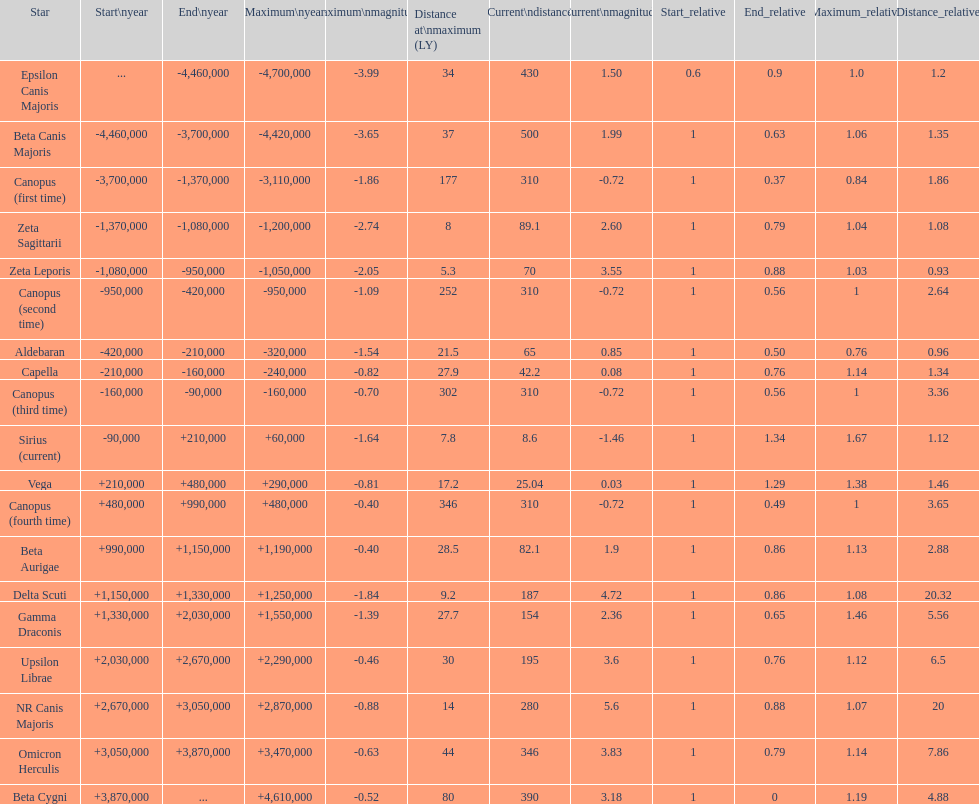Help me parse the entirety of this table. {'header': ['Star', 'Start\\nyear', 'End\\nyear', 'Maximum\\nyear', 'Maximum\\nmagnitude', 'Distance at\\nmaximum (LY)', 'Current\\ndistance', 'Current\\nmagnitude', 'Start_relative', 'End_relative', 'Maximum_relative', 'Distance_relative'], 'rows': [['Epsilon Canis Majoris', '...', '-4,460,000', '-4,700,000', '-3.99', '34', '430', '1.50', '0.6', '0.9', '1.0', '1.2'], ['Beta Canis Majoris', '-4,460,000', '-3,700,000', '-4,420,000', '-3.65', '37', '500', '1.99', '1', '0.63', '1.06', '1.35'], ['Canopus (first time)', '-3,700,000', '-1,370,000', '-3,110,000', '-1.86', '177', '310', '-0.72', '1', '0.37', '0.84', '1.86'], ['Zeta Sagittarii', '-1,370,000', '-1,080,000', '-1,200,000', '-2.74', '8', '89.1', '2.60', '1', '0.79', '1.04', '1.08'], ['Zeta Leporis', '-1,080,000', '-950,000', '-1,050,000', '-2.05', '5.3', '70', '3.55', '1', '0.88', '1.03', '0.93'], ['Canopus (second time)', '-950,000', '-420,000', '-950,000', '-1.09', '252', '310', '-0.72', '1', '0.56', '1', '2.64'], ['Aldebaran', '-420,000', '-210,000', '-320,000', '-1.54', '21.5', '65', '0.85', '1', '0.50', '0.76', '0.96'], ['Capella', '-210,000', '-160,000', '-240,000', '-0.82', '27.9', '42.2', '0.08', '1', '0.76', '1.14', '1.34'], ['Canopus (third time)', '-160,000', '-90,000', '-160,000', '-0.70', '302', '310', '-0.72', '1', '0.56', '1', '3.36'], ['Sirius (current)', '-90,000', '+210,000', '+60,000', '-1.64', '7.8', '8.6', '-1.46', '1', '1.34', '1.67', '1.12'], ['Vega', '+210,000', '+480,000', '+290,000', '-0.81', '17.2', '25.04', '0.03', '1', '1.29', '1.38', '1.46'], ['Canopus (fourth time)', '+480,000', '+990,000', '+480,000', '-0.40', '346', '310', '-0.72', '1', '0.49', '1', '3.65'], ['Beta Aurigae', '+990,000', '+1,150,000', '+1,190,000', '-0.40', '28.5', '82.1', '1.9', '1', '0.86', '1.13', '2.88'], ['Delta Scuti', '+1,150,000', '+1,330,000', '+1,250,000', '-1.84', '9.2', '187', '4.72', '1', '0.86', '1.08', '20.32'], ['Gamma Draconis', '+1,330,000', '+2,030,000', '+1,550,000', '-1.39', '27.7', '154', '2.36', '1', '0.65', '1.46', '5.56'], ['Upsilon Librae', '+2,030,000', '+2,670,000', '+2,290,000', '-0.46', '30', '195', '3.6', '1', '0.76', '1.12', '6.5'], ['NR Canis Majoris', '+2,670,000', '+3,050,000', '+2,870,000', '-0.88', '14', '280', '5.6', '1', '0.88', '1.07', '20'], ['Omicron Herculis', '+3,050,000', '+3,870,000', '+3,470,000', '-0.63', '44', '346', '3.83', '1', '0.79', '1.14', '7.86'], ['Beta Cygni', '+3,870,000', '...', '+4,610,000', '-0.52', '80', '390', '3.18', '1', '0', '1.19', '4.88']]} Which star has the highest distance at maximum? Canopus (fourth time). 